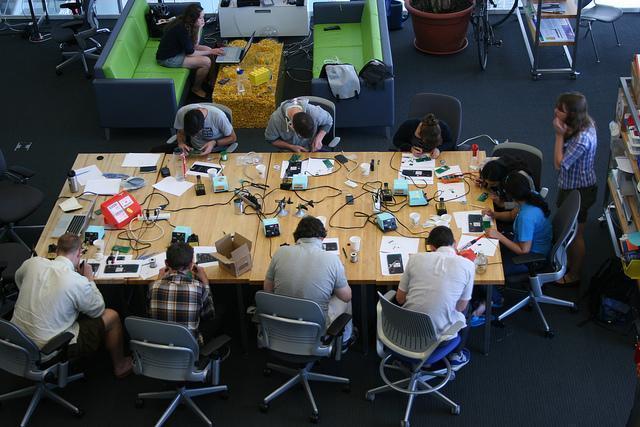What would soon stop here if there were a power outage?
Select the accurate response from the four choices given to answer the question.
Options: Nothing, all work, parties, silence. All work. 